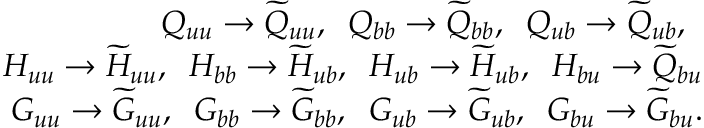Convert formula to latex. <formula><loc_0><loc_0><loc_500><loc_500>\begin{array} { r l r } & { Q _ { u u } \to \widetilde { Q } _ { u u } , \, Q _ { b b } \to \widetilde { Q } _ { b b } , \, Q _ { u b } \to \widetilde { Q } _ { u b } , \, } \\ & { H _ { u u } \to \widetilde { H } _ { u u } , \, H _ { b b } \to \widetilde { H } _ { u b } , \, H _ { u b } \to \widetilde { H } _ { u b } , \, H _ { b u } \to \widetilde { Q } _ { b u } } \\ & { G _ { u u } \to \widetilde { G } _ { u u } , \, G _ { b b } \to \widetilde { G } _ { b b } , \, G _ { u b } \to \widetilde { G } _ { u b } , \, G _ { b u } \to \widetilde { G } _ { b u } . } \end{array}</formula> 